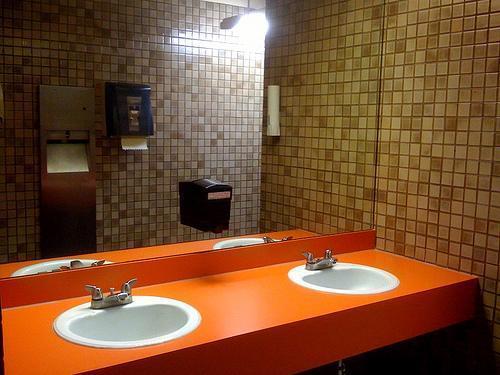How many sinks can you see?
Give a very brief answer. 2. How many umbrellas are in the picture?
Give a very brief answer. 0. 